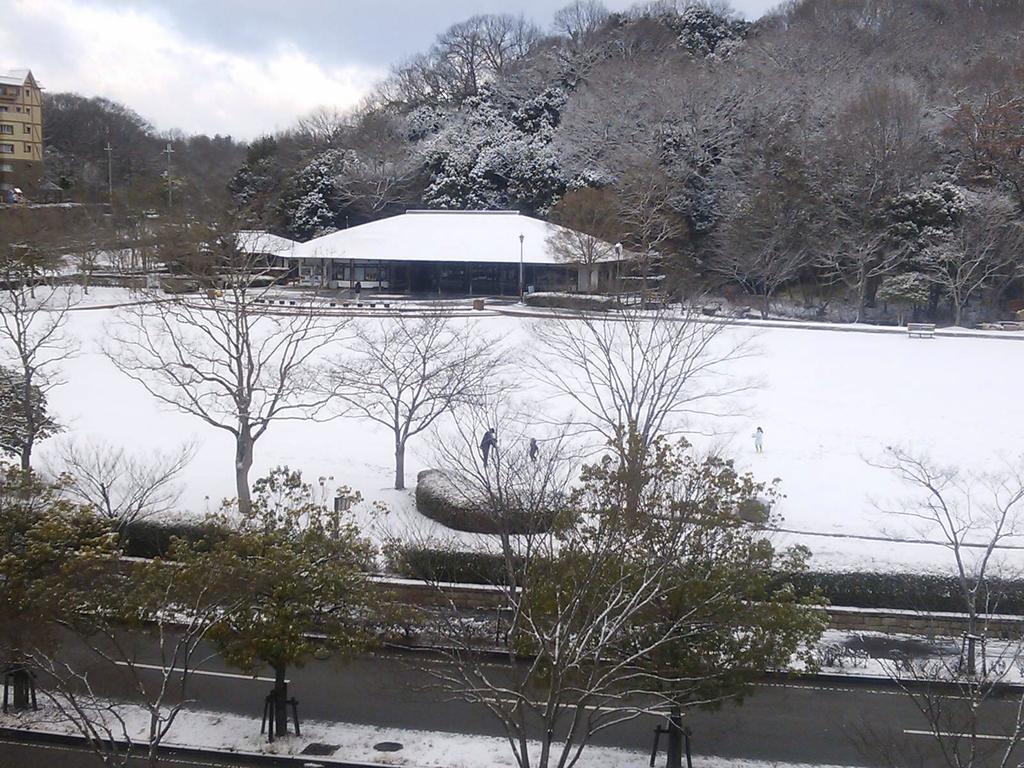Please provide a concise description of this image. In the foreground of the image we can see snow and trees, In the middle of the image we can see snow, a house and some persons. On the top of the image we can see the sky, building and some trees. 